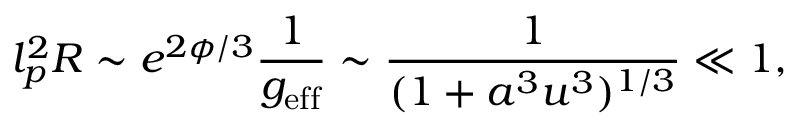<formula> <loc_0><loc_0><loc_500><loc_500>l _ { p } ^ { 2 } R \sim e ^ { 2 \phi / 3 } \frac { 1 } { g _ { e f f } } \sim \frac { 1 } { ( 1 + a ^ { 3 } u ^ { 3 } ) ^ { 1 / 3 } } \ll 1 ,</formula> 